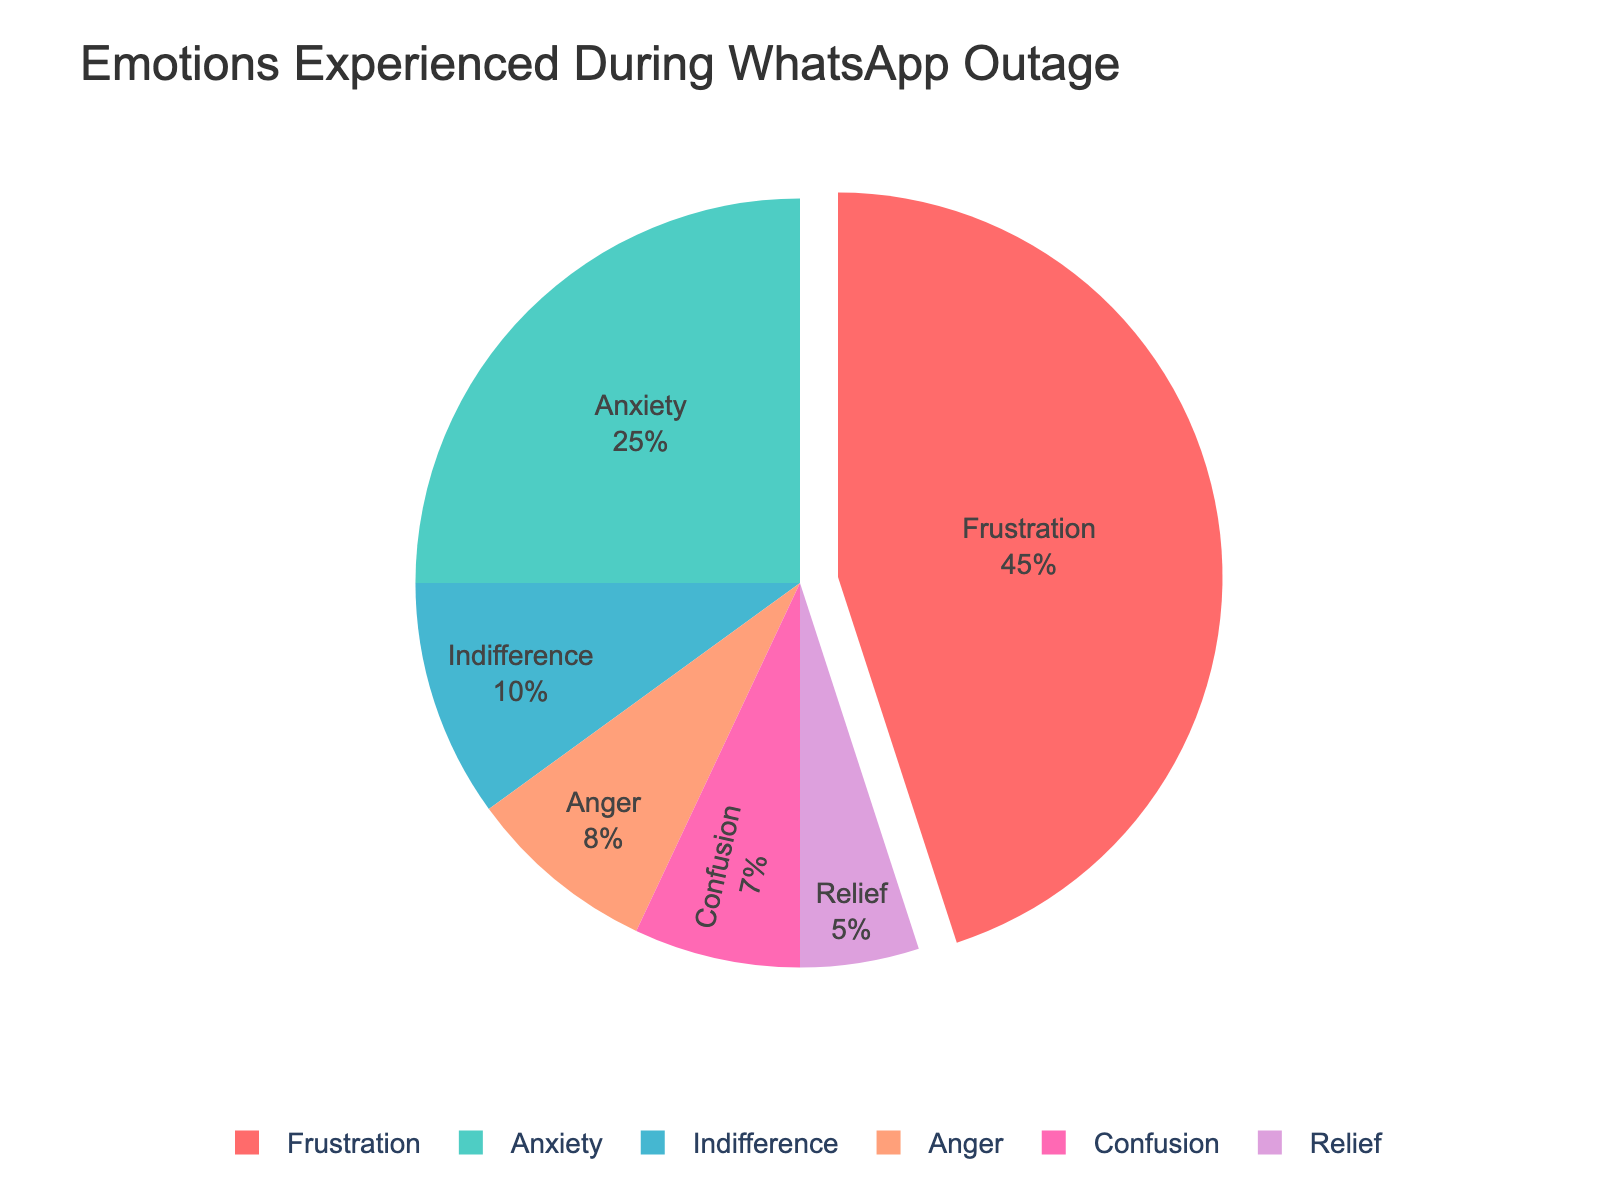What's the total percentage of people who experienced negative emotions during the outage (Frustration, Anxiety, Anger, and Confusion)? The negative emotions listed are Frustration, Anxiety, Anger, and Confusion. Summing their percentages: 45% (Frustration) + 25% (Anxiety) + 8% (Anger) + 7% (Confusion) = 85%
Answer: 85% Which emotion had the highest share during the WhatsApp outage? By looking at the pie chart, the largest slice represents Frustration with a percentage of 45%.
Answer: Frustration How much more common was Frustration compared to Indifference? The percentage of Frustration is 45% and Indifference is 10%. The difference is 45% - 10% = 35%.
Answer: 35% Out of all the emotions listed, which one was experienced the least during the outage? By identifying the smallest slice on the pie chart, Relief has the smallest percentage at 5%.
Answer: Relief What percentage of people experienced positive or neutral emotions (Relief and Indifference) during the outage? The positive or neutral emotions are Relief and Indifference with percentages of 5% and 10% respectively. Summing them: 5% + 10% = 15%
Answer: 15% How did the percentage of people feeling Anxiety compare to those feeling Anger and Confusion combined? The percentage of Anxiety is 25%, while Anger and Confusion combined are 8% + 7% = 15%. So, Anxiety (25%) is 25% - 15% = 10% more than Anger and Confusion combined.
Answer: 10% Which emotions made up more than 50% of the total experience when combined? By summing the highest percentages: Frustration (45%) and Anxiety (25%) sum to 70%, which is more than 50%.
Answer: Frustration and Anxiety What percentage of people felt emotions other than Frustration? Subtract the percentage of Frustration from 100%: 100% - 45% = 55%.
Answer: 55% Compare the magnitudes of Relief and Anger shown in the pie chart. The percentage of Relief is 5%, and the percentage of Anger is 8%. Anger is 3% more than Relief.
Answer: 3% How does the sum of percentages of neutral or positive emotions (Indifference and Relief) compare to Anxiety? The sum of neutral or positive emotions Indifference and Relief is 10% + 5% = 15%, which is less than the percentage for Anxiety (25%).
Answer: Less (15% vs 25%) 